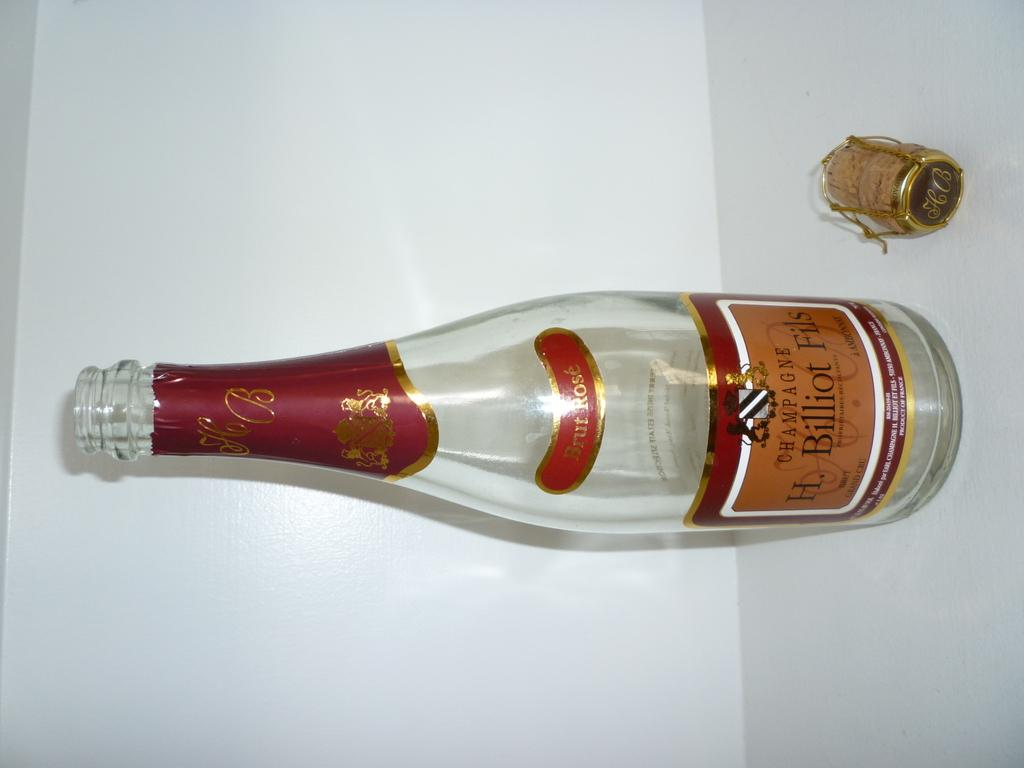Provide a one-sentence caption for the provided image. An empty bottle of H. Biilliot Fils champagne sits on a counter. 